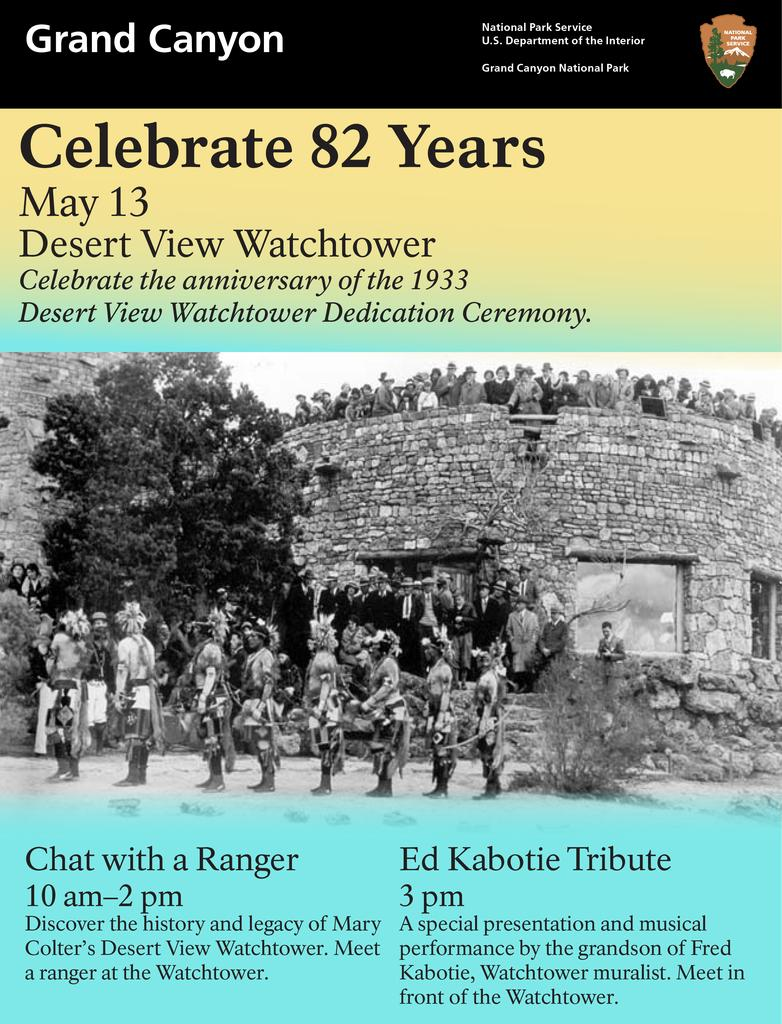<image>
Provide a brief description of the given image. 82 years celebratory poster for the grand canyon lists events people can attend. 